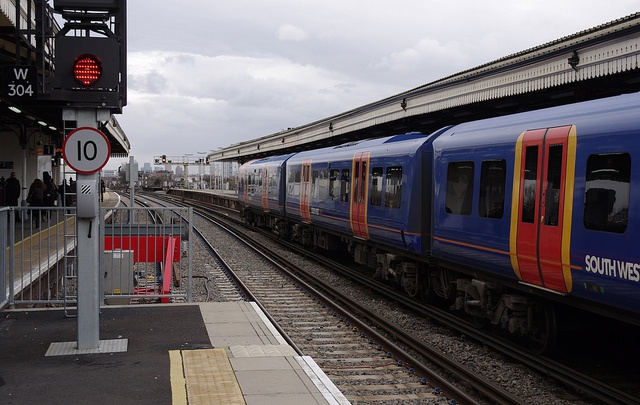Describe the objects in this image and their specific colors. I can see train in darkgray, black, navy, and maroon tones, traffic light in darkgray, black, maroon, brown, and red tones, people in darkgray, black, and gray tones, people in darkgray, black, and gray tones, and people in darkgray, black, and gray tones in this image. 